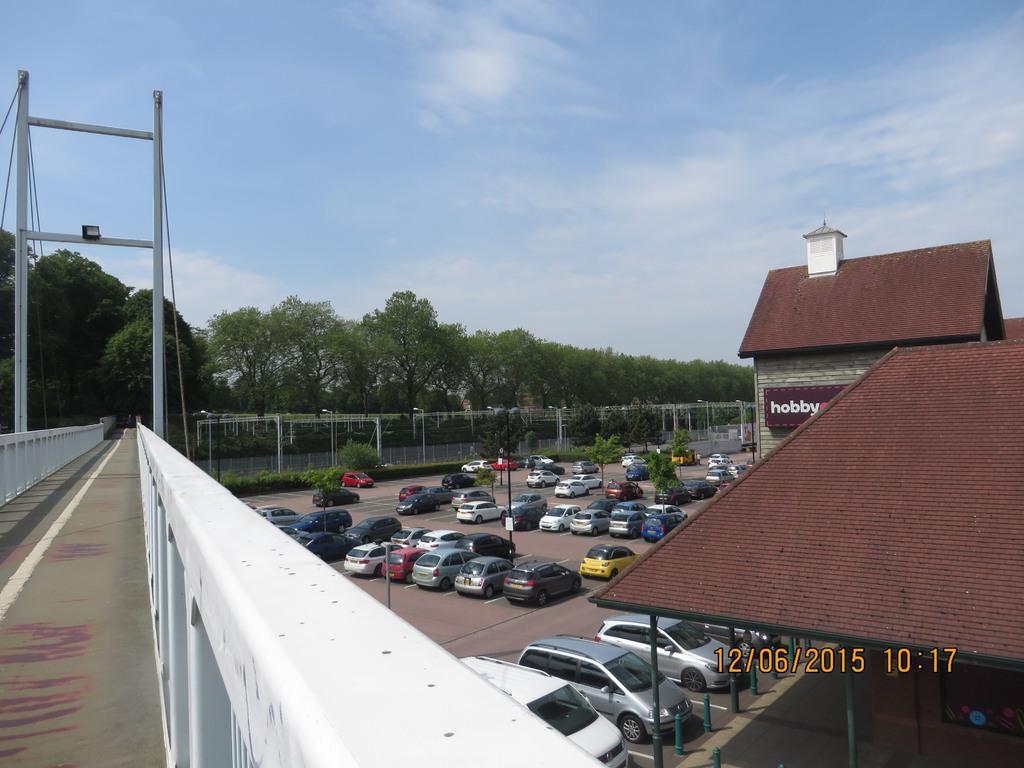How would you summarize this image in a sentence or two? In the image there is a bridge and under the bridge on the right side there are many cars parked in the ground. In front of the cars there is a shelter and a building, behind the cars there are many trees. 